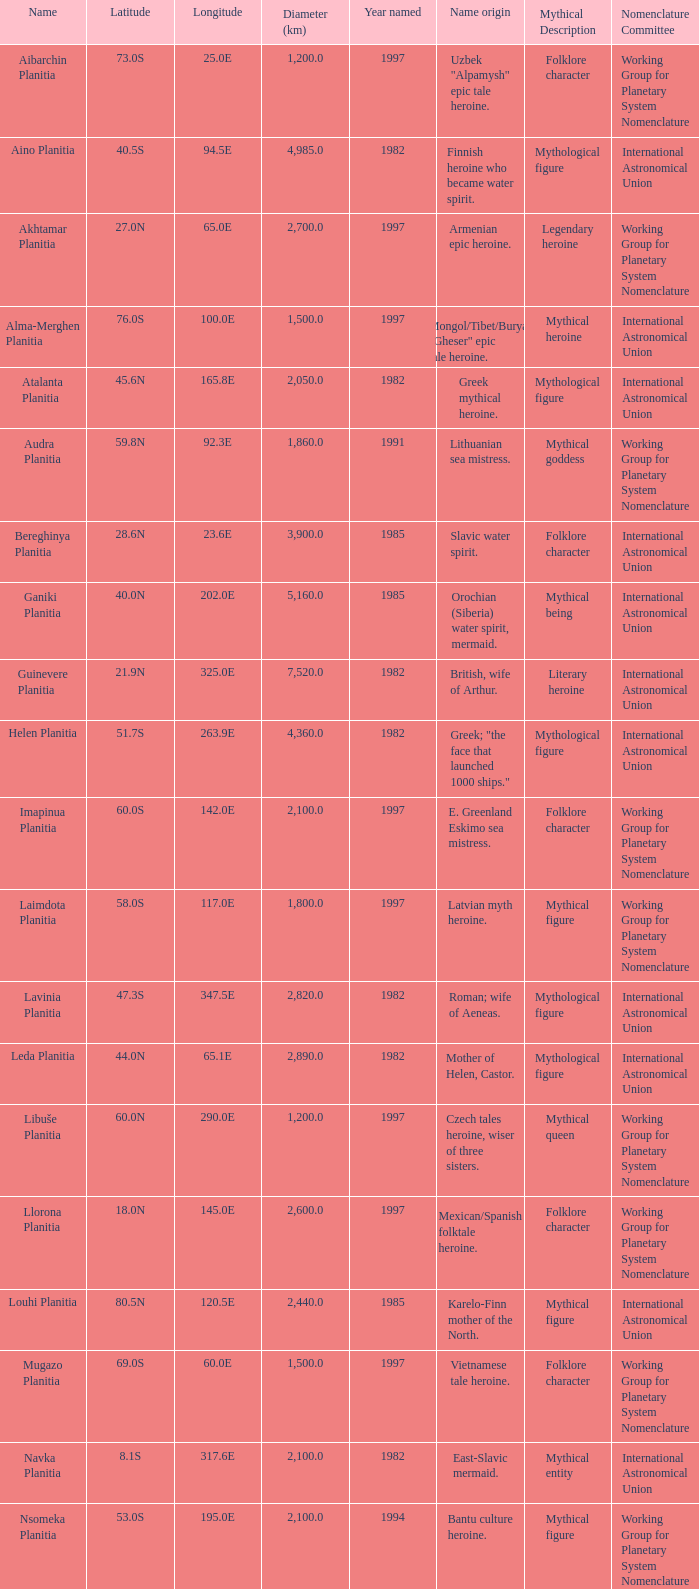Would you be able to parse every entry in this table? {'header': ['Name', 'Latitude', 'Longitude', 'Diameter (km)', 'Year named', 'Name origin', 'Mythical Description', 'Nomenclature Committee'], 'rows': [['Aibarchin Planitia', '73.0S', '25.0E', '1,200.0', '1997', 'Uzbek "Alpamysh" epic tale heroine.', 'Folklore character', 'Working Group for Planetary System Nomenclature '], ['Aino Planitia', '40.5S', '94.5E', '4,985.0', '1982', 'Finnish heroine who became water spirit.', 'Mythological figure', 'International Astronomical Union '], ['Akhtamar Planitia', '27.0N', '65.0E', '2,700.0', '1997', 'Armenian epic heroine.', 'Legendary heroine', 'Working Group for Planetary System Nomenclature '], ['Alma-Merghen Planitia', '76.0S', '100.0E', '1,500.0', '1997', 'Mongol/Tibet/Buryat "Gheser" epic tale heroine.', 'Mythical heroine', 'International Astronomical Union '], ['Atalanta Planitia', '45.6N', '165.8E', '2,050.0', '1982', 'Greek mythical heroine.', 'Mythological figure', 'International Astronomical Union '], ['Audra Planitia', '59.8N', '92.3E', '1,860.0', '1991', 'Lithuanian sea mistress.', 'Mythical goddess', 'Working Group for Planetary System Nomenclature '], ['Bereghinya Planitia', '28.6N', '23.6E', '3,900.0', '1985', 'Slavic water spirit.', 'Folklore character', 'International Astronomical Union '], ['Ganiki Planitia', '40.0N', '202.0E', '5,160.0', '1985', 'Orochian (Siberia) water spirit, mermaid.', 'Mythical being', 'International Astronomical Union '], ['Guinevere Planitia', '21.9N', '325.0E', '7,520.0', '1982', 'British, wife of Arthur.', 'Literary heroine', 'International Astronomical Union '], ['Helen Planitia', '51.7S', '263.9E', '4,360.0', '1982', 'Greek; "the face that launched 1000 ships."', 'Mythological figure', 'International Astronomical Union '], ['Imapinua Planitia', '60.0S', '142.0E', '2,100.0', '1997', 'E. Greenland Eskimo sea mistress.', 'Folklore character', 'Working Group for Planetary System Nomenclature '], ['Laimdota Planitia', '58.0S', '117.0E', '1,800.0', '1997', 'Latvian myth heroine.', 'Mythical figure', 'Working Group for Planetary System Nomenclature '], ['Lavinia Planitia', '47.3S', '347.5E', '2,820.0', '1982', 'Roman; wife of Aeneas.', 'Mythological figure', 'International Astronomical Union '], ['Leda Planitia', '44.0N', '65.1E', '2,890.0', '1982', 'Mother of Helen, Castor.', 'Mythological figure', 'International Astronomical Union '], ['Libuše Planitia', '60.0N', '290.0E', '1,200.0', '1997', 'Czech tales heroine, wiser of three sisters.', 'Mythical queen', 'Working Group for Planetary System Nomenclature '], ['Llorona Planitia', '18.0N', '145.0E', '2,600.0', '1997', 'Mexican/Spanish folktale heroine.', 'Folklore character', 'Working Group for Planetary System Nomenclature '], ['Louhi Planitia', '80.5N', '120.5E', '2,440.0', '1985', 'Karelo-Finn mother of the North.', 'Mythical figure', 'International Astronomical Union '], ['Mugazo Planitia', '69.0S', '60.0E', '1,500.0', '1997', 'Vietnamese tale heroine.', 'Folklore character', 'Working Group for Planetary System Nomenclature '], ['Navka Planitia', '8.1S', '317.6E', '2,100.0', '1982', 'East-Slavic mermaid.', 'Mythical entity', 'International Astronomical Union '], ['Nsomeka Planitia', '53.0S', '195.0E', '2,100.0', '1994', 'Bantu culture heroine.', 'Mythical figure', 'Working Group for Planetary System Nomenclature '], ['Rusalka Planitia', '9.8N', '170.1E', '3,655.0', '1982', 'Russian mermaid.', 'Mythological character', 'International Astronomical Union '], ['Sedna Planitia', '42.7N', '340.7E', '3,570.0', '1982', 'Eskimo; her fingers became seals and whales.', 'Mythical figure', 'International Astronomical Union '], ['Tahmina Planitia', '23.0S', '80.0E', '3,000.0', '1997', 'Iranian epic heroine, wife of knight Rustam.', 'Mythical character', 'Working Group for Planetary System Nomenclature '], ['Tilli-Hanum Planitia', '54.0N', '120.0E', '2,300.0', '1997', 'Azeri "Ker-ogly" epic tale heroine.', 'Folklore figure', 'Working Group for Planetary System Nomenclature '], ['Tinatin Planitia', '15.0S', '15.0E', '0.0', '1994', 'Georgian epic heroine.', 'Mythical character', 'Working Group for Planetary System Nomenclature '], ['Undine Planitia', '13.0N', '303.0E', '2,800.0', '1997', 'Lithuanian water nymph, mermaid.', 'Mythical creature', 'Working Group for Planetary System Nomenclature '], ['Vellamo Planitia', '45.4N', '149.1E', '2,155.0', '1985', 'Karelo-Finn mermaid.', 'Mythological figure', 'International Astronomical Union']]} What's the name origin of feature of diameter (km) 2,155.0 Karelo-Finn mermaid. 